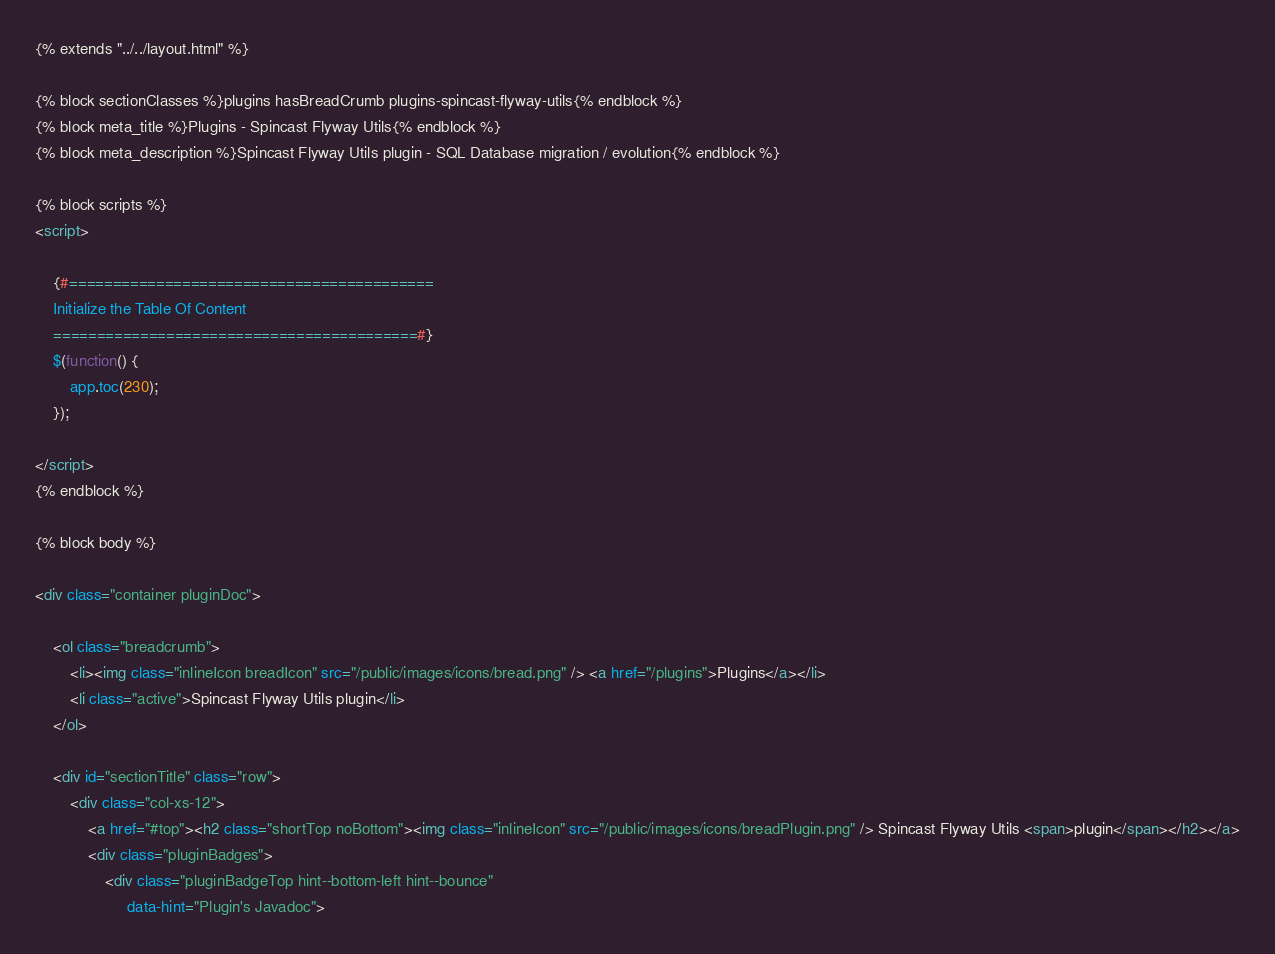<code> <loc_0><loc_0><loc_500><loc_500><_HTML_>{% extends "../../layout.html" %}

{% block sectionClasses %}plugins hasBreadCrumb plugins-spincast-flyway-utils{% endblock %}
{% block meta_title %}Plugins - Spincast Flyway Utils{% endblock %}
{% block meta_description %}Spincast Flyway Utils plugin - SQL Database migration / evolution{% endblock %}

{% block scripts %}
<script>

    {#==========================================
    Initialize the Table Of Content
    ==========================================#}
    $(function() {
        app.toc(230);
    });

</script>
{% endblock %}

{% block body %}

<div class="container pluginDoc">

    <ol class="breadcrumb">
        <li><img class="inlineIcon breadIcon" src="/public/images/icons/bread.png" /> <a href="/plugins">Plugins</a></li>
        <li class="active">Spincast Flyway Utils plugin</li>
    </ol>
    
    <div id="sectionTitle" class="row"> 
        <div class="col-xs-12"> 
            <a href="#top"><h2 class="shortTop noBottom"><img class="inlineIcon" src="/public/images/icons/breadPlugin.png" /> Spincast Flyway Utils <span>plugin</span></h2></a>
            <div class="pluginBadges">
                <div class="pluginBadgeTop hint--bottom-left hint--bounce" 
                     data-hint="Plugin's Javadoc"></code> 